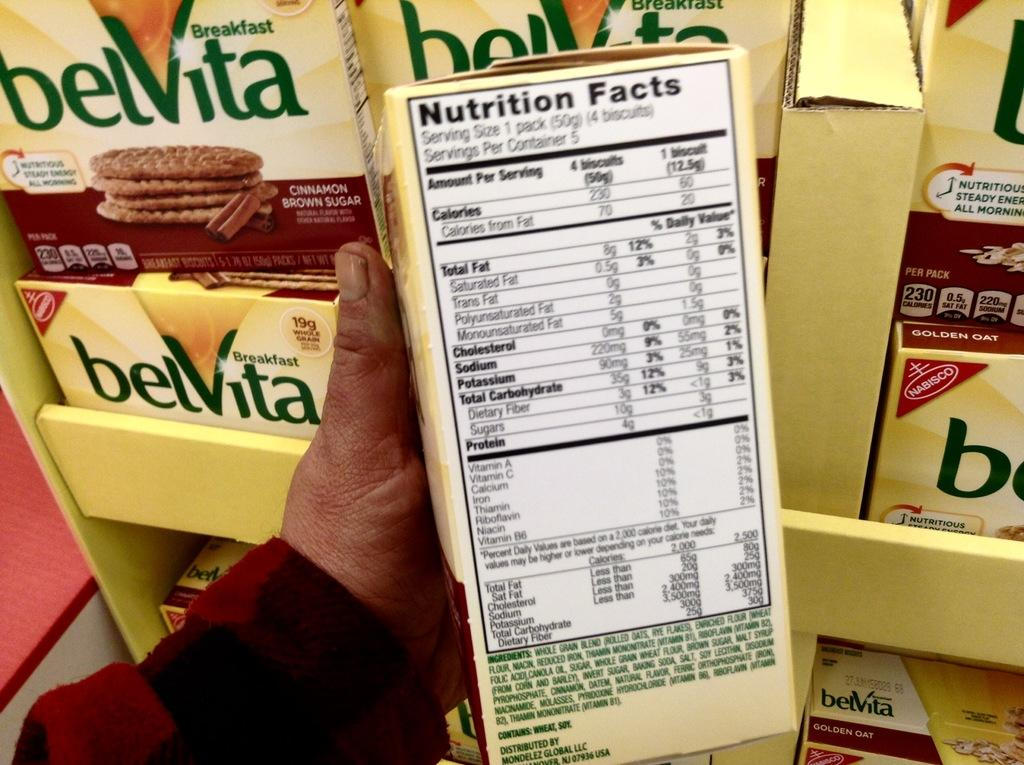Provide a one-sentence caption for the provided image. A person is holding a box of golden oat belVita with the nutritional facts displayed. 